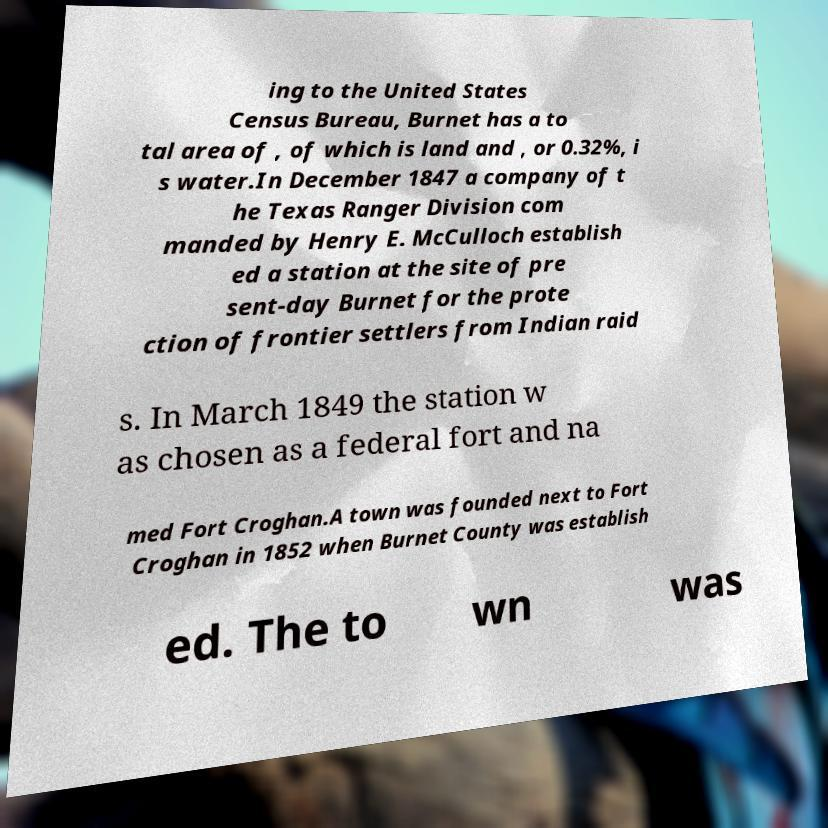Can you read and provide the text displayed in the image?This photo seems to have some interesting text. Can you extract and type it out for me? ing to the United States Census Bureau, Burnet has a to tal area of , of which is land and , or 0.32%, i s water.In December 1847 a company of t he Texas Ranger Division com manded by Henry E. McCulloch establish ed a station at the site of pre sent-day Burnet for the prote ction of frontier settlers from Indian raid s. In March 1849 the station w as chosen as a federal fort and na med Fort Croghan.A town was founded next to Fort Croghan in 1852 when Burnet County was establish ed. The to wn was 